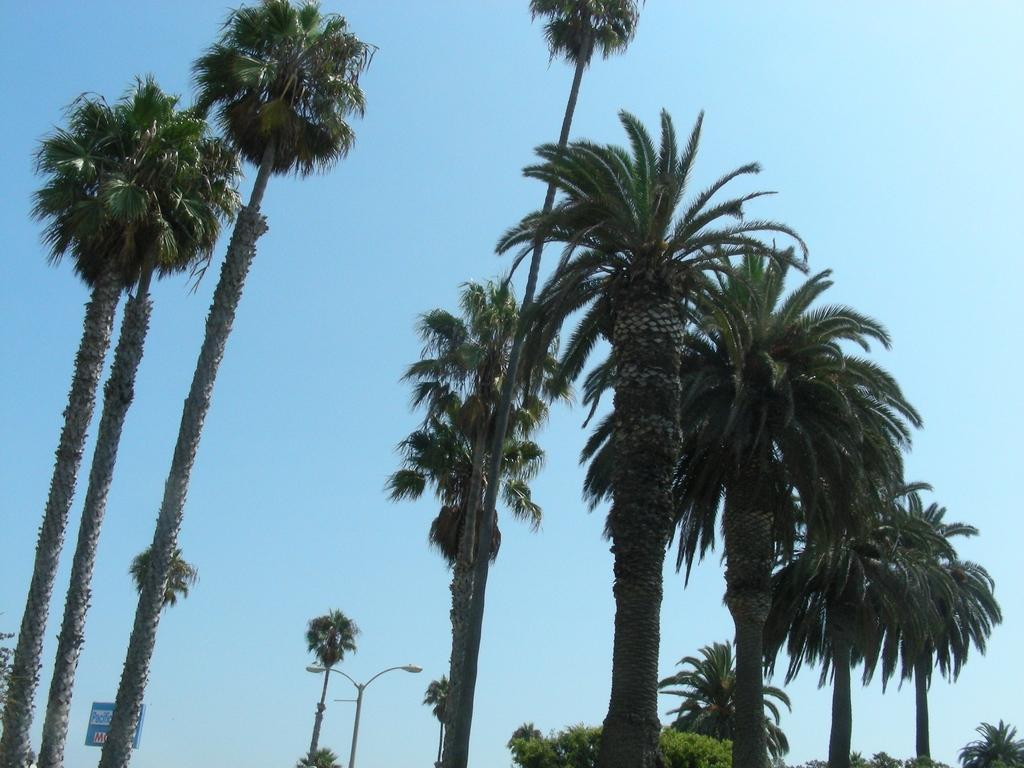What type of vegetation is visible in the image? There are trees in the image. What object can be seen standing upright in the image? There is a pole in the image. What color is the sky in the background of the image? The background of the image includes a blue sky. How many kittens are playing in the park in the image? There are no kittens or park present in the image; it only features trees and a pole. What type of authority figure can be seen in the image? There is no authority figure present in the image. 